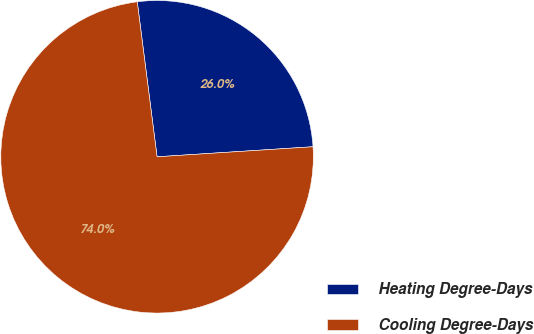Convert chart to OTSL. <chart><loc_0><loc_0><loc_500><loc_500><pie_chart><fcel>Heating Degree-Days<fcel>Cooling Degree-Days<nl><fcel>26.0%<fcel>74.0%<nl></chart> 